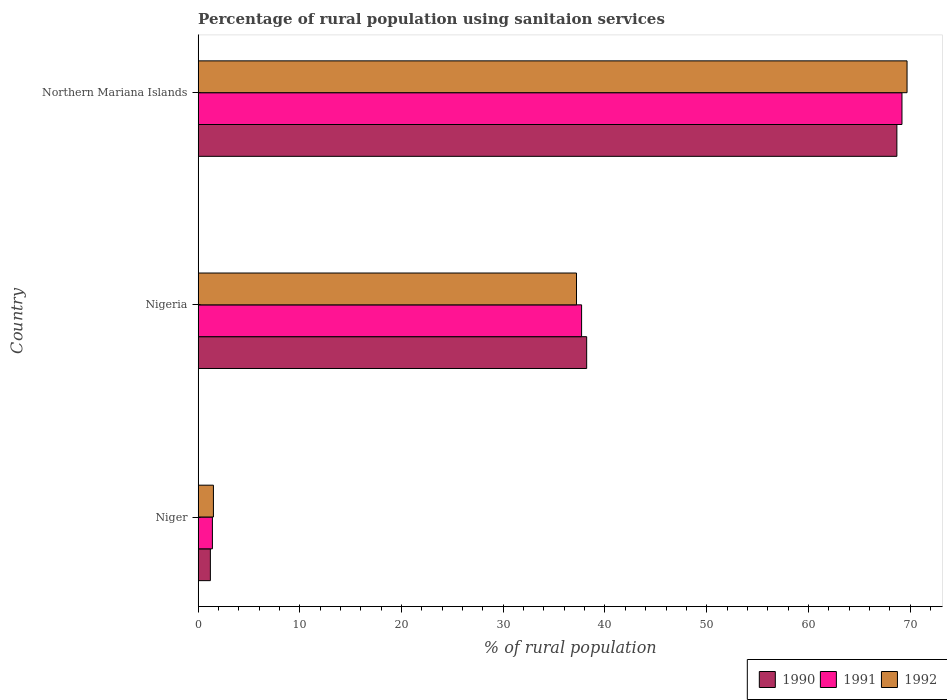How many different coloured bars are there?
Offer a very short reply. 3. How many groups of bars are there?
Provide a short and direct response. 3. Are the number of bars per tick equal to the number of legend labels?
Provide a succinct answer. Yes. Are the number of bars on each tick of the Y-axis equal?
Ensure brevity in your answer.  Yes. What is the label of the 2nd group of bars from the top?
Give a very brief answer. Nigeria. Across all countries, what is the maximum percentage of rural population using sanitaion services in 1990?
Your answer should be compact. 68.7. Across all countries, what is the minimum percentage of rural population using sanitaion services in 1991?
Ensure brevity in your answer.  1.4. In which country was the percentage of rural population using sanitaion services in 1991 maximum?
Make the answer very short. Northern Mariana Islands. In which country was the percentage of rural population using sanitaion services in 1990 minimum?
Ensure brevity in your answer.  Niger. What is the total percentage of rural population using sanitaion services in 1990 in the graph?
Give a very brief answer. 108.1. What is the difference between the percentage of rural population using sanitaion services in 1990 in Niger and that in Northern Mariana Islands?
Your answer should be very brief. -67.5. What is the average percentage of rural population using sanitaion services in 1990 per country?
Offer a very short reply. 36.03. In how many countries, is the percentage of rural population using sanitaion services in 1990 greater than 68 %?
Ensure brevity in your answer.  1. What is the ratio of the percentage of rural population using sanitaion services in 1992 in Niger to that in Nigeria?
Your answer should be compact. 0.04. Is the difference between the percentage of rural population using sanitaion services in 1992 in Niger and Nigeria greater than the difference between the percentage of rural population using sanitaion services in 1991 in Niger and Nigeria?
Make the answer very short. Yes. What is the difference between the highest and the second highest percentage of rural population using sanitaion services in 1991?
Your answer should be very brief. 31.5. What is the difference between the highest and the lowest percentage of rural population using sanitaion services in 1992?
Ensure brevity in your answer.  68.2. In how many countries, is the percentage of rural population using sanitaion services in 1990 greater than the average percentage of rural population using sanitaion services in 1990 taken over all countries?
Give a very brief answer. 2. Is the sum of the percentage of rural population using sanitaion services in 1990 in Nigeria and Northern Mariana Islands greater than the maximum percentage of rural population using sanitaion services in 1992 across all countries?
Offer a terse response. Yes. How many bars are there?
Offer a terse response. 9. How many countries are there in the graph?
Give a very brief answer. 3. Does the graph contain grids?
Your answer should be compact. No. Where does the legend appear in the graph?
Give a very brief answer. Bottom right. How are the legend labels stacked?
Offer a terse response. Horizontal. What is the title of the graph?
Keep it short and to the point. Percentage of rural population using sanitaion services. What is the label or title of the X-axis?
Keep it short and to the point. % of rural population. What is the % of rural population of 1990 in Niger?
Ensure brevity in your answer.  1.2. What is the % of rural population of 1991 in Niger?
Give a very brief answer. 1.4. What is the % of rural population in 1990 in Nigeria?
Keep it short and to the point. 38.2. What is the % of rural population in 1991 in Nigeria?
Provide a short and direct response. 37.7. What is the % of rural population in 1992 in Nigeria?
Ensure brevity in your answer.  37.2. What is the % of rural population of 1990 in Northern Mariana Islands?
Your answer should be compact. 68.7. What is the % of rural population of 1991 in Northern Mariana Islands?
Keep it short and to the point. 69.2. What is the % of rural population in 1992 in Northern Mariana Islands?
Provide a succinct answer. 69.7. Across all countries, what is the maximum % of rural population of 1990?
Offer a very short reply. 68.7. Across all countries, what is the maximum % of rural population of 1991?
Keep it short and to the point. 69.2. Across all countries, what is the maximum % of rural population in 1992?
Provide a succinct answer. 69.7. Across all countries, what is the minimum % of rural population of 1990?
Provide a short and direct response. 1.2. Across all countries, what is the minimum % of rural population in 1991?
Your answer should be compact. 1.4. Across all countries, what is the minimum % of rural population of 1992?
Offer a terse response. 1.5. What is the total % of rural population of 1990 in the graph?
Offer a terse response. 108.1. What is the total % of rural population in 1991 in the graph?
Keep it short and to the point. 108.3. What is the total % of rural population of 1992 in the graph?
Provide a short and direct response. 108.4. What is the difference between the % of rural population in 1990 in Niger and that in Nigeria?
Your response must be concise. -37. What is the difference between the % of rural population in 1991 in Niger and that in Nigeria?
Your response must be concise. -36.3. What is the difference between the % of rural population of 1992 in Niger and that in Nigeria?
Offer a terse response. -35.7. What is the difference between the % of rural population of 1990 in Niger and that in Northern Mariana Islands?
Provide a short and direct response. -67.5. What is the difference between the % of rural population in 1991 in Niger and that in Northern Mariana Islands?
Make the answer very short. -67.8. What is the difference between the % of rural population of 1992 in Niger and that in Northern Mariana Islands?
Your response must be concise. -68.2. What is the difference between the % of rural population of 1990 in Nigeria and that in Northern Mariana Islands?
Give a very brief answer. -30.5. What is the difference between the % of rural population in 1991 in Nigeria and that in Northern Mariana Islands?
Offer a terse response. -31.5. What is the difference between the % of rural population in 1992 in Nigeria and that in Northern Mariana Islands?
Keep it short and to the point. -32.5. What is the difference between the % of rural population in 1990 in Niger and the % of rural population in 1991 in Nigeria?
Provide a short and direct response. -36.5. What is the difference between the % of rural population in 1990 in Niger and the % of rural population in 1992 in Nigeria?
Ensure brevity in your answer.  -36. What is the difference between the % of rural population in 1991 in Niger and the % of rural population in 1992 in Nigeria?
Ensure brevity in your answer.  -35.8. What is the difference between the % of rural population in 1990 in Niger and the % of rural population in 1991 in Northern Mariana Islands?
Your answer should be compact. -68. What is the difference between the % of rural population in 1990 in Niger and the % of rural population in 1992 in Northern Mariana Islands?
Your answer should be very brief. -68.5. What is the difference between the % of rural population of 1991 in Niger and the % of rural population of 1992 in Northern Mariana Islands?
Provide a succinct answer. -68.3. What is the difference between the % of rural population of 1990 in Nigeria and the % of rural population of 1991 in Northern Mariana Islands?
Your answer should be compact. -31. What is the difference between the % of rural population in 1990 in Nigeria and the % of rural population in 1992 in Northern Mariana Islands?
Keep it short and to the point. -31.5. What is the difference between the % of rural population in 1991 in Nigeria and the % of rural population in 1992 in Northern Mariana Islands?
Offer a terse response. -32. What is the average % of rural population of 1990 per country?
Provide a succinct answer. 36.03. What is the average % of rural population in 1991 per country?
Provide a short and direct response. 36.1. What is the average % of rural population in 1992 per country?
Provide a succinct answer. 36.13. What is the difference between the % of rural population in 1990 and % of rural population in 1991 in Niger?
Make the answer very short. -0.2. What is the difference between the % of rural population in 1990 and % of rural population in 1992 in Niger?
Your answer should be very brief. -0.3. What is the difference between the % of rural population in 1991 and % of rural population in 1992 in Niger?
Offer a terse response. -0.1. What is the difference between the % of rural population in 1990 and % of rural population in 1991 in Northern Mariana Islands?
Your answer should be compact. -0.5. What is the difference between the % of rural population of 1991 and % of rural population of 1992 in Northern Mariana Islands?
Provide a short and direct response. -0.5. What is the ratio of the % of rural population in 1990 in Niger to that in Nigeria?
Offer a terse response. 0.03. What is the ratio of the % of rural population in 1991 in Niger to that in Nigeria?
Offer a terse response. 0.04. What is the ratio of the % of rural population in 1992 in Niger to that in Nigeria?
Keep it short and to the point. 0.04. What is the ratio of the % of rural population in 1990 in Niger to that in Northern Mariana Islands?
Your answer should be very brief. 0.02. What is the ratio of the % of rural population of 1991 in Niger to that in Northern Mariana Islands?
Your answer should be compact. 0.02. What is the ratio of the % of rural population of 1992 in Niger to that in Northern Mariana Islands?
Your answer should be very brief. 0.02. What is the ratio of the % of rural population in 1990 in Nigeria to that in Northern Mariana Islands?
Offer a terse response. 0.56. What is the ratio of the % of rural population in 1991 in Nigeria to that in Northern Mariana Islands?
Your answer should be compact. 0.54. What is the ratio of the % of rural population in 1992 in Nigeria to that in Northern Mariana Islands?
Your response must be concise. 0.53. What is the difference between the highest and the second highest % of rural population in 1990?
Make the answer very short. 30.5. What is the difference between the highest and the second highest % of rural population of 1991?
Provide a short and direct response. 31.5. What is the difference between the highest and the second highest % of rural population of 1992?
Offer a very short reply. 32.5. What is the difference between the highest and the lowest % of rural population of 1990?
Offer a terse response. 67.5. What is the difference between the highest and the lowest % of rural population in 1991?
Your response must be concise. 67.8. What is the difference between the highest and the lowest % of rural population of 1992?
Make the answer very short. 68.2. 